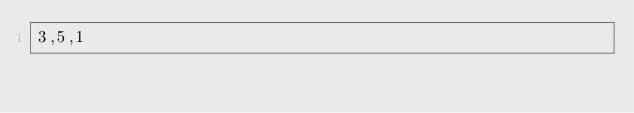<code> <loc_0><loc_0><loc_500><loc_500><_C_>3,5,1
</code> 